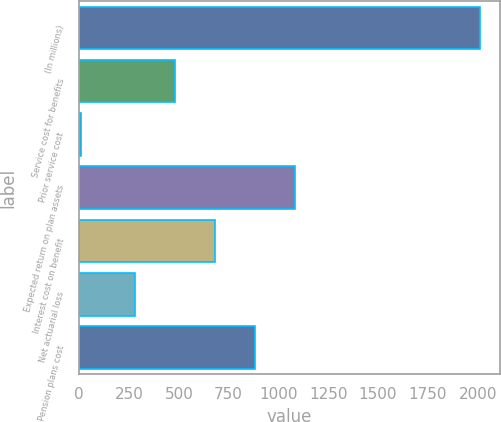<chart> <loc_0><loc_0><loc_500><loc_500><bar_chart><fcel>(In millions)<fcel>Service cost for benefits<fcel>Prior service cost<fcel>Expected return on plan assets<fcel>Interest cost on benefit<fcel>Net actuarial loss<fcel>Pension plans cost<nl><fcel>2012<fcel>480.4<fcel>8<fcel>1081.6<fcel>680.8<fcel>280<fcel>881.2<nl></chart> 